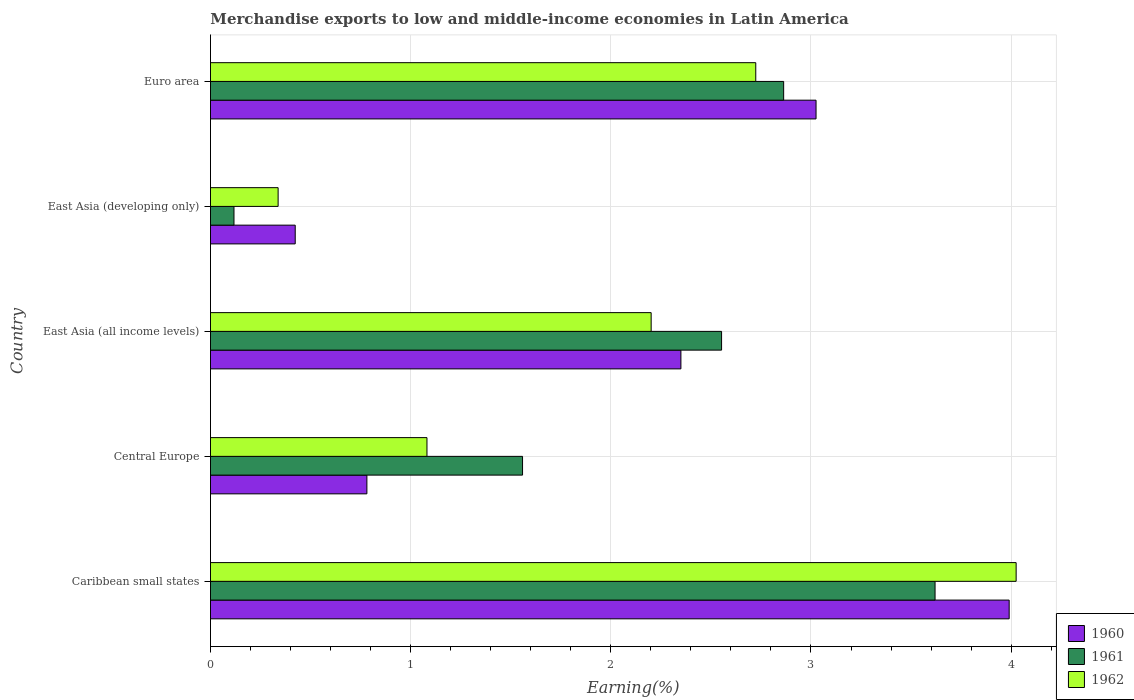How many groups of bars are there?
Give a very brief answer. 5. How many bars are there on the 1st tick from the top?
Your answer should be very brief. 3. What is the label of the 5th group of bars from the top?
Offer a very short reply. Caribbean small states. In how many cases, is the number of bars for a given country not equal to the number of legend labels?
Your answer should be compact. 0. What is the percentage of amount earned from merchandise exports in 1962 in Caribbean small states?
Your response must be concise. 4.02. Across all countries, what is the maximum percentage of amount earned from merchandise exports in 1961?
Offer a very short reply. 3.62. Across all countries, what is the minimum percentage of amount earned from merchandise exports in 1961?
Provide a short and direct response. 0.12. In which country was the percentage of amount earned from merchandise exports in 1961 maximum?
Keep it short and to the point. Caribbean small states. In which country was the percentage of amount earned from merchandise exports in 1961 minimum?
Provide a short and direct response. East Asia (developing only). What is the total percentage of amount earned from merchandise exports in 1960 in the graph?
Provide a succinct answer. 10.57. What is the difference between the percentage of amount earned from merchandise exports in 1962 in Caribbean small states and that in Euro area?
Give a very brief answer. 1.3. What is the difference between the percentage of amount earned from merchandise exports in 1962 in East Asia (all income levels) and the percentage of amount earned from merchandise exports in 1961 in East Asia (developing only)?
Provide a succinct answer. 2.08. What is the average percentage of amount earned from merchandise exports in 1962 per country?
Your response must be concise. 2.07. What is the difference between the percentage of amount earned from merchandise exports in 1962 and percentage of amount earned from merchandise exports in 1960 in Caribbean small states?
Make the answer very short. 0.03. What is the ratio of the percentage of amount earned from merchandise exports in 1961 in Central Europe to that in Euro area?
Your answer should be very brief. 0.54. What is the difference between the highest and the second highest percentage of amount earned from merchandise exports in 1961?
Give a very brief answer. 0.76. What is the difference between the highest and the lowest percentage of amount earned from merchandise exports in 1961?
Your response must be concise. 3.5. Is the sum of the percentage of amount earned from merchandise exports in 1962 in Central Europe and East Asia (developing only) greater than the maximum percentage of amount earned from merchandise exports in 1961 across all countries?
Provide a succinct answer. No. What does the 1st bar from the top in Caribbean small states represents?
Provide a succinct answer. 1962. What does the 3rd bar from the bottom in Central Europe represents?
Give a very brief answer. 1962. Is it the case that in every country, the sum of the percentage of amount earned from merchandise exports in 1960 and percentage of amount earned from merchandise exports in 1962 is greater than the percentage of amount earned from merchandise exports in 1961?
Give a very brief answer. Yes. What is the difference between two consecutive major ticks on the X-axis?
Provide a short and direct response. 1. Does the graph contain grids?
Your answer should be compact. Yes. Where does the legend appear in the graph?
Offer a very short reply. Bottom right. How are the legend labels stacked?
Offer a terse response. Vertical. What is the title of the graph?
Keep it short and to the point. Merchandise exports to low and middle-income economies in Latin America. Does "1990" appear as one of the legend labels in the graph?
Offer a terse response. No. What is the label or title of the X-axis?
Give a very brief answer. Earning(%). What is the label or title of the Y-axis?
Give a very brief answer. Country. What is the Earning(%) of 1960 in Caribbean small states?
Provide a succinct answer. 3.99. What is the Earning(%) of 1961 in Caribbean small states?
Offer a very short reply. 3.62. What is the Earning(%) of 1962 in Caribbean small states?
Your response must be concise. 4.02. What is the Earning(%) in 1960 in Central Europe?
Make the answer very short. 0.78. What is the Earning(%) in 1961 in Central Europe?
Offer a terse response. 1.56. What is the Earning(%) in 1962 in Central Europe?
Provide a short and direct response. 1.08. What is the Earning(%) in 1960 in East Asia (all income levels)?
Make the answer very short. 2.35. What is the Earning(%) of 1961 in East Asia (all income levels)?
Your response must be concise. 2.55. What is the Earning(%) of 1962 in East Asia (all income levels)?
Your answer should be very brief. 2.2. What is the Earning(%) of 1960 in East Asia (developing only)?
Your answer should be very brief. 0.42. What is the Earning(%) of 1961 in East Asia (developing only)?
Provide a short and direct response. 0.12. What is the Earning(%) of 1962 in East Asia (developing only)?
Ensure brevity in your answer.  0.34. What is the Earning(%) of 1960 in Euro area?
Your answer should be very brief. 3.03. What is the Earning(%) of 1961 in Euro area?
Ensure brevity in your answer.  2.86. What is the Earning(%) in 1962 in Euro area?
Provide a short and direct response. 2.72. Across all countries, what is the maximum Earning(%) of 1960?
Provide a short and direct response. 3.99. Across all countries, what is the maximum Earning(%) in 1961?
Your answer should be compact. 3.62. Across all countries, what is the maximum Earning(%) of 1962?
Your response must be concise. 4.02. Across all countries, what is the minimum Earning(%) of 1960?
Your answer should be compact. 0.42. Across all countries, what is the minimum Earning(%) in 1961?
Offer a terse response. 0.12. Across all countries, what is the minimum Earning(%) in 1962?
Give a very brief answer. 0.34. What is the total Earning(%) in 1960 in the graph?
Keep it short and to the point. 10.57. What is the total Earning(%) of 1961 in the graph?
Your answer should be compact. 10.71. What is the total Earning(%) in 1962 in the graph?
Your answer should be very brief. 10.37. What is the difference between the Earning(%) in 1960 in Caribbean small states and that in Central Europe?
Your answer should be very brief. 3.21. What is the difference between the Earning(%) of 1961 in Caribbean small states and that in Central Europe?
Make the answer very short. 2.06. What is the difference between the Earning(%) of 1962 in Caribbean small states and that in Central Europe?
Offer a terse response. 2.94. What is the difference between the Earning(%) in 1960 in Caribbean small states and that in East Asia (all income levels)?
Your response must be concise. 1.64. What is the difference between the Earning(%) of 1961 in Caribbean small states and that in East Asia (all income levels)?
Give a very brief answer. 1.07. What is the difference between the Earning(%) in 1962 in Caribbean small states and that in East Asia (all income levels)?
Keep it short and to the point. 1.82. What is the difference between the Earning(%) in 1960 in Caribbean small states and that in East Asia (developing only)?
Your response must be concise. 3.57. What is the difference between the Earning(%) in 1961 in Caribbean small states and that in East Asia (developing only)?
Your answer should be very brief. 3.5. What is the difference between the Earning(%) in 1962 in Caribbean small states and that in East Asia (developing only)?
Make the answer very short. 3.69. What is the difference between the Earning(%) in 1960 in Caribbean small states and that in Euro area?
Make the answer very short. 0.96. What is the difference between the Earning(%) of 1961 in Caribbean small states and that in Euro area?
Make the answer very short. 0.76. What is the difference between the Earning(%) in 1962 in Caribbean small states and that in Euro area?
Provide a succinct answer. 1.3. What is the difference between the Earning(%) in 1960 in Central Europe and that in East Asia (all income levels)?
Your response must be concise. -1.57. What is the difference between the Earning(%) in 1961 in Central Europe and that in East Asia (all income levels)?
Ensure brevity in your answer.  -0.99. What is the difference between the Earning(%) in 1962 in Central Europe and that in East Asia (all income levels)?
Make the answer very short. -1.12. What is the difference between the Earning(%) of 1960 in Central Europe and that in East Asia (developing only)?
Make the answer very short. 0.36. What is the difference between the Earning(%) in 1961 in Central Europe and that in East Asia (developing only)?
Your answer should be compact. 1.44. What is the difference between the Earning(%) of 1962 in Central Europe and that in East Asia (developing only)?
Make the answer very short. 0.74. What is the difference between the Earning(%) of 1960 in Central Europe and that in Euro area?
Provide a succinct answer. -2.24. What is the difference between the Earning(%) in 1961 in Central Europe and that in Euro area?
Provide a short and direct response. -1.3. What is the difference between the Earning(%) in 1962 in Central Europe and that in Euro area?
Make the answer very short. -1.64. What is the difference between the Earning(%) of 1960 in East Asia (all income levels) and that in East Asia (developing only)?
Keep it short and to the point. 1.93. What is the difference between the Earning(%) in 1961 in East Asia (all income levels) and that in East Asia (developing only)?
Give a very brief answer. 2.44. What is the difference between the Earning(%) of 1962 in East Asia (all income levels) and that in East Asia (developing only)?
Your response must be concise. 1.86. What is the difference between the Earning(%) in 1960 in East Asia (all income levels) and that in Euro area?
Your response must be concise. -0.68. What is the difference between the Earning(%) in 1961 in East Asia (all income levels) and that in Euro area?
Provide a succinct answer. -0.31. What is the difference between the Earning(%) of 1962 in East Asia (all income levels) and that in Euro area?
Your response must be concise. -0.52. What is the difference between the Earning(%) in 1960 in East Asia (developing only) and that in Euro area?
Keep it short and to the point. -2.6. What is the difference between the Earning(%) in 1961 in East Asia (developing only) and that in Euro area?
Your answer should be compact. -2.75. What is the difference between the Earning(%) of 1962 in East Asia (developing only) and that in Euro area?
Offer a terse response. -2.39. What is the difference between the Earning(%) of 1960 in Caribbean small states and the Earning(%) of 1961 in Central Europe?
Keep it short and to the point. 2.43. What is the difference between the Earning(%) of 1960 in Caribbean small states and the Earning(%) of 1962 in Central Europe?
Provide a succinct answer. 2.91. What is the difference between the Earning(%) in 1961 in Caribbean small states and the Earning(%) in 1962 in Central Europe?
Keep it short and to the point. 2.54. What is the difference between the Earning(%) in 1960 in Caribbean small states and the Earning(%) in 1961 in East Asia (all income levels)?
Ensure brevity in your answer.  1.44. What is the difference between the Earning(%) of 1960 in Caribbean small states and the Earning(%) of 1962 in East Asia (all income levels)?
Keep it short and to the point. 1.79. What is the difference between the Earning(%) of 1961 in Caribbean small states and the Earning(%) of 1962 in East Asia (all income levels)?
Give a very brief answer. 1.42. What is the difference between the Earning(%) of 1960 in Caribbean small states and the Earning(%) of 1961 in East Asia (developing only)?
Offer a very short reply. 3.87. What is the difference between the Earning(%) in 1960 in Caribbean small states and the Earning(%) in 1962 in East Asia (developing only)?
Your answer should be compact. 3.65. What is the difference between the Earning(%) of 1961 in Caribbean small states and the Earning(%) of 1962 in East Asia (developing only)?
Give a very brief answer. 3.28. What is the difference between the Earning(%) of 1960 in Caribbean small states and the Earning(%) of 1961 in Euro area?
Keep it short and to the point. 1.13. What is the difference between the Earning(%) of 1960 in Caribbean small states and the Earning(%) of 1962 in Euro area?
Provide a succinct answer. 1.27. What is the difference between the Earning(%) in 1961 in Caribbean small states and the Earning(%) in 1962 in Euro area?
Provide a succinct answer. 0.9. What is the difference between the Earning(%) in 1960 in Central Europe and the Earning(%) in 1961 in East Asia (all income levels)?
Keep it short and to the point. -1.77. What is the difference between the Earning(%) of 1960 in Central Europe and the Earning(%) of 1962 in East Asia (all income levels)?
Your answer should be very brief. -1.42. What is the difference between the Earning(%) of 1961 in Central Europe and the Earning(%) of 1962 in East Asia (all income levels)?
Make the answer very short. -0.64. What is the difference between the Earning(%) of 1960 in Central Europe and the Earning(%) of 1961 in East Asia (developing only)?
Ensure brevity in your answer.  0.66. What is the difference between the Earning(%) of 1960 in Central Europe and the Earning(%) of 1962 in East Asia (developing only)?
Your answer should be compact. 0.44. What is the difference between the Earning(%) of 1961 in Central Europe and the Earning(%) of 1962 in East Asia (developing only)?
Offer a terse response. 1.22. What is the difference between the Earning(%) in 1960 in Central Europe and the Earning(%) in 1961 in Euro area?
Provide a short and direct response. -2.08. What is the difference between the Earning(%) in 1960 in Central Europe and the Earning(%) in 1962 in Euro area?
Your answer should be very brief. -1.94. What is the difference between the Earning(%) in 1961 in Central Europe and the Earning(%) in 1962 in Euro area?
Provide a short and direct response. -1.17. What is the difference between the Earning(%) in 1960 in East Asia (all income levels) and the Earning(%) in 1961 in East Asia (developing only)?
Make the answer very short. 2.23. What is the difference between the Earning(%) in 1960 in East Asia (all income levels) and the Earning(%) in 1962 in East Asia (developing only)?
Provide a short and direct response. 2.01. What is the difference between the Earning(%) in 1961 in East Asia (all income levels) and the Earning(%) in 1962 in East Asia (developing only)?
Your response must be concise. 2.22. What is the difference between the Earning(%) in 1960 in East Asia (all income levels) and the Earning(%) in 1961 in Euro area?
Offer a very short reply. -0.51. What is the difference between the Earning(%) in 1960 in East Asia (all income levels) and the Earning(%) in 1962 in Euro area?
Offer a very short reply. -0.37. What is the difference between the Earning(%) in 1961 in East Asia (all income levels) and the Earning(%) in 1962 in Euro area?
Make the answer very short. -0.17. What is the difference between the Earning(%) of 1960 in East Asia (developing only) and the Earning(%) of 1961 in Euro area?
Make the answer very short. -2.44. What is the difference between the Earning(%) in 1960 in East Asia (developing only) and the Earning(%) in 1962 in Euro area?
Make the answer very short. -2.3. What is the difference between the Earning(%) in 1961 in East Asia (developing only) and the Earning(%) in 1962 in Euro area?
Offer a terse response. -2.61. What is the average Earning(%) of 1960 per country?
Offer a terse response. 2.11. What is the average Earning(%) in 1961 per country?
Keep it short and to the point. 2.14. What is the average Earning(%) in 1962 per country?
Keep it short and to the point. 2.07. What is the difference between the Earning(%) of 1960 and Earning(%) of 1961 in Caribbean small states?
Provide a succinct answer. 0.37. What is the difference between the Earning(%) of 1960 and Earning(%) of 1962 in Caribbean small states?
Provide a succinct answer. -0.03. What is the difference between the Earning(%) of 1961 and Earning(%) of 1962 in Caribbean small states?
Your answer should be very brief. -0.41. What is the difference between the Earning(%) of 1960 and Earning(%) of 1961 in Central Europe?
Ensure brevity in your answer.  -0.78. What is the difference between the Earning(%) in 1960 and Earning(%) in 1962 in Central Europe?
Give a very brief answer. -0.3. What is the difference between the Earning(%) of 1961 and Earning(%) of 1962 in Central Europe?
Your response must be concise. 0.48. What is the difference between the Earning(%) of 1960 and Earning(%) of 1961 in East Asia (all income levels)?
Your answer should be very brief. -0.2. What is the difference between the Earning(%) of 1960 and Earning(%) of 1962 in East Asia (all income levels)?
Offer a very short reply. 0.15. What is the difference between the Earning(%) in 1961 and Earning(%) in 1962 in East Asia (all income levels)?
Keep it short and to the point. 0.35. What is the difference between the Earning(%) of 1960 and Earning(%) of 1961 in East Asia (developing only)?
Provide a short and direct response. 0.31. What is the difference between the Earning(%) of 1960 and Earning(%) of 1962 in East Asia (developing only)?
Keep it short and to the point. 0.09. What is the difference between the Earning(%) of 1961 and Earning(%) of 1962 in East Asia (developing only)?
Keep it short and to the point. -0.22. What is the difference between the Earning(%) in 1960 and Earning(%) in 1961 in Euro area?
Offer a terse response. 0.16. What is the difference between the Earning(%) in 1960 and Earning(%) in 1962 in Euro area?
Your answer should be very brief. 0.3. What is the difference between the Earning(%) in 1961 and Earning(%) in 1962 in Euro area?
Your response must be concise. 0.14. What is the ratio of the Earning(%) of 1960 in Caribbean small states to that in Central Europe?
Keep it short and to the point. 5.11. What is the ratio of the Earning(%) of 1961 in Caribbean small states to that in Central Europe?
Provide a succinct answer. 2.32. What is the ratio of the Earning(%) of 1962 in Caribbean small states to that in Central Europe?
Your answer should be very brief. 3.72. What is the ratio of the Earning(%) in 1960 in Caribbean small states to that in East Asia (all income levels)?
Your answer should be very brief. 1.7. What is the ratio of the Earning(%) in 1961 in Caribbean small states to that in East Asia (all income levels)?
Make the answer very short. 1.42. What is the ratio of the Earning(%) of 1962 in Caribbean small states to that in East Asia (all income levels)?
Give a very brief answer. 1.83. What is the ratio of the Earning(%) of 1960 in Caribbean small states to that in East Asia (developing only)?
Your answer should be very brief. 9.42. What is the ratio of the Earning(%) in 1961 in Caribbean small states to that in East Asia (developing only)?
Ensure brevity in your answer.  30.82. What is the ratio of the Earning(%) of 1962 in Caribbean small states to that in East Asia (developing only)?
Your answer should be very brief. 11.91. What is the ratio of the Earning(%) in 1960 in Caribbean small states to that in Euro area?
Your response must be concise. 1.32. What is the ratio of the Earning(%) in 1961 in Caribbean small states to that in Euro area?
Your answer should be very brief. 1.26. What is the ratio of the Earning(%) of 1962 in Caribbean small states to that in Euro area?
Your response must be concise. 1.48. What is the ratio of the Earning(%) of 1960 in Central Europe to that in East Asia (all income levels)?
Ensure brevity in your answer.  0.33. What is the ratio of the Earning(%) in 1961 in Central Europe to that in East Asia (all income levels)?
Provide a short and direct response. 0.61. What is the ratio of the Earning(%) in 1962 in Central Europe to that in East Asia (all income levels)?
Give a very brief answer. 0.49. What is the ratio of the Earning(%) of 1960 in Central Europe to that in East Asia (developing only)?
Your answer should be very brief. 1.85. What is the ratio of the Earning(%) of 1961 in Central Europe to that in East Asia (developing only)?
Your response must be concise. 13.28. What is the ratio of the Earning(%) in 1962 in Central Europe to that in East Asia (developing only)?
Ensure brevity in your answer.  3.2. What is the ratio of the Earning(%) in 1960 in Central Europe to that in Euro area?
Provide a succinct answer. 0.26. What is the ratio of the Earning(%) in 1961 in Central Europe to that in Euro area?
Offer a very short reply. 0.54. What is the ratio of the Earning(%) of 1962 in Central Europe to that in Euro area?
Offer a very short reply. 0.4. What is the ratio of the Earning(%) of 1960 in East Asia (all income levels) to that in East Asia (developing only)?
Your answer should be very brief. 5.55. What is the ratio of the Earning(%) of 1961 in East Asia (all income levels) to that in East Asia (developing only)?
Your response must be concise. 21.74. What is the ratio of the Earning(%) in 1962 in East Asia (all income levels) to that in East Asia (developing only)?
Your answer should be compact. 6.51. What is the ratio of the Earning(%) of 1960 in East Asia (all income levels) to that in Euro area?
Your answer should be compact. 0.78. What is the ratio of the Earning(%) of 1961 in East Asia (all income levels) to that in Euro area?
Offer a very short reply. 0.89. What is the ratio of the Earning(%) in 1962 in East Asia (all income levels) to that in Euro area?
Your response must be concise. 0.81. What is the ratio of the Earning(%) of 1960 in East Asia (developing only) to that in Euro area?
Offer a terse response. 0.14. What is the ratio of the Earning(%) of 1961 in East Asia (developing only) to that in Euro area?
Offer a very short reply. 0.04. What is the ratio of the Earning(%) in 1962 in East Asia (developing only) to that in Euro area?
Offer a very short reply. 0.12. What is the difference between the highest and the second highest Earning(%) of 1960?
Give a very brief answer. 0.96. What is the difference between the highest and the second highest Earning(%) in 1961?
Give a very brief answer. 0.76. What is the difference between the highest and the second highest Earning(%) in 1962?
Make the answer very short. 1.3. What is the difference between the highest and the lowest Earning(%) in 1960?
Make the answer very short. 3.57. What is the difference between the highest and the lowest Earning(%) of 1961?
Provide a short and direct response. 3.5. What is the difference between the highest and the lowest Earning(%) in 1962?
Your response must be concise. 3.69. 